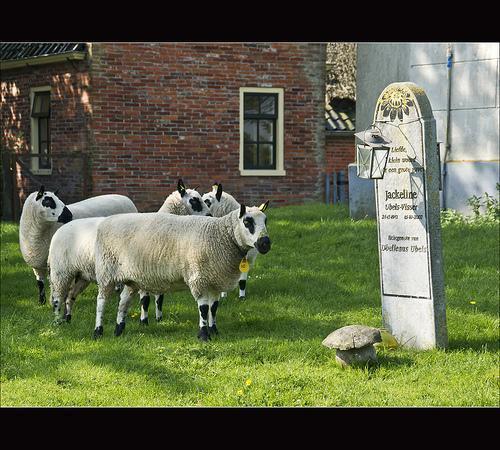How many animals are in this picture?
Give a very brief answer. 4. How many windows are in this picture?
Give a very brief answer. 2. 